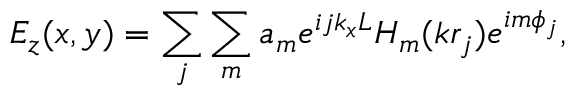Convert formula to latex. <formula><loc_0><loc_0><loc_500><loc_500>E _ { z } ( x , y ) = \sum _ { j } \sum _ { m } a _ { m } e ^ { i j k _ { x } L } H _ { m } ( k r _ { j } ) e ^ { i m \phi _ { j } } ,</formula> 